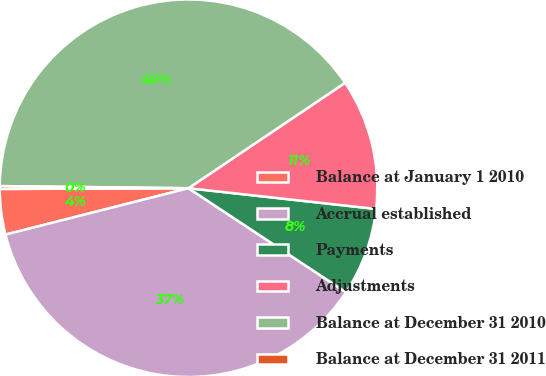Convert chart to OTSL. <chart><loc_0><loc_0><loc_500><loc_500><pie_chart><fcel>Balance at January 1 2010<fcel>Accrual established<fcel>Payments<fcel>Adjustments<fcel>Balance at December 31 2010<fcel>Balance at December 31 2011<nl><fcel>3.89%<fcel>36.75%<fcel>7.54%<fcel>11.18%<fcel>40.39%<fcel>0.24%<nl></chart> 